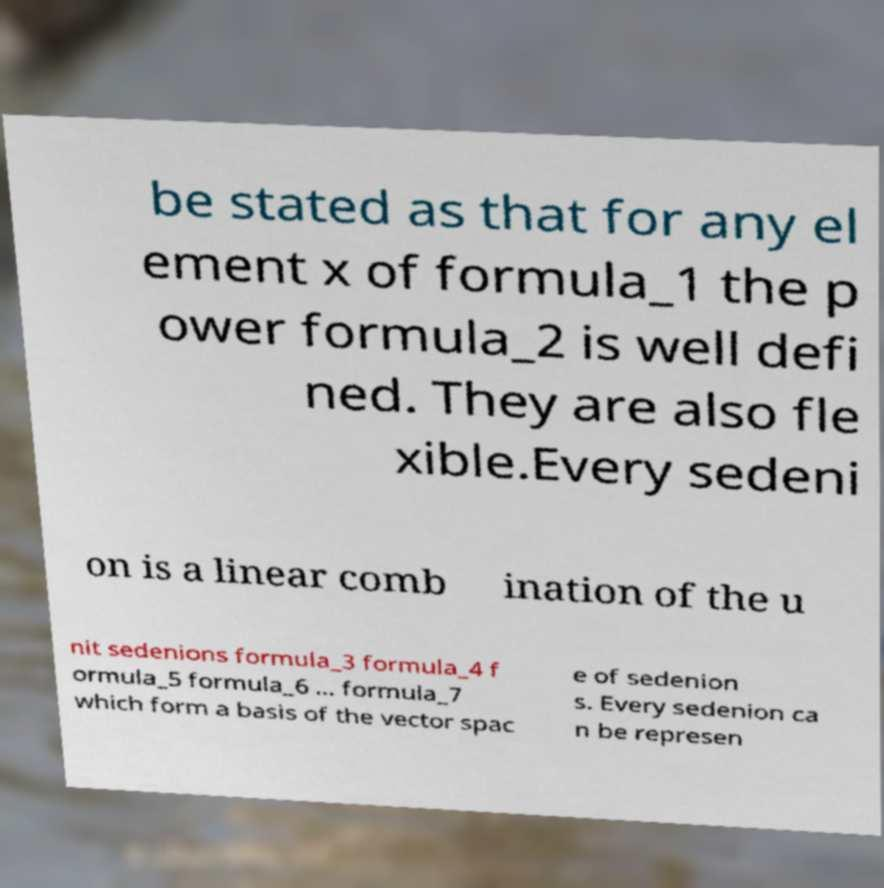What messages or text are displayed in this image? I need them in a readable, typed format. be stated as that for any el ement x of formula_1 the p ower formula_2 is well defi ned. They are also fle xible.Every sedeni on is a linear comb ination of the u nit sedenions formula_3 formula_4 f ormula_5 formula_6 ... formula_7 which form a basis of the vector spac e of sedenion s. Every sedenion ca n be represen 